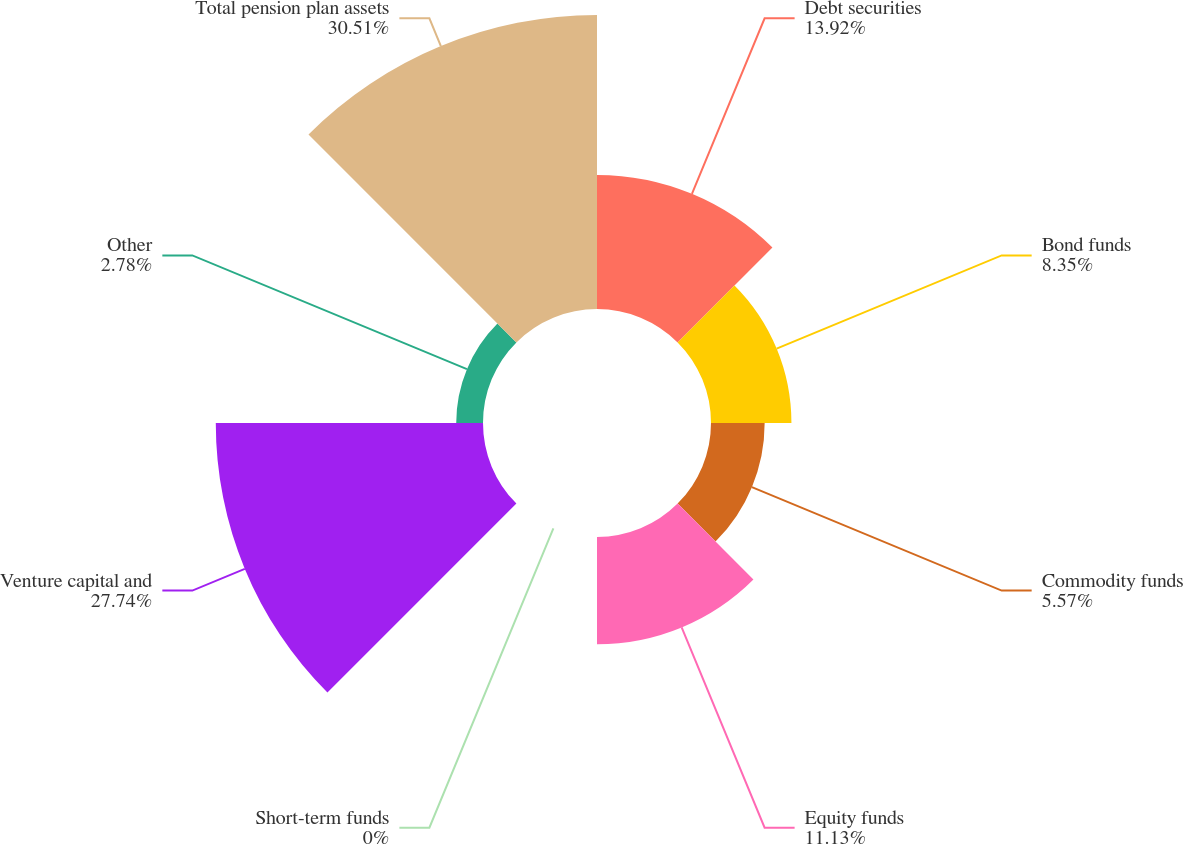Convert chart. <chart><loc_0><loc_0><loc_500><loc_500><pie_chart><fcel>Debt securities<fcel>Bond funds<fcel>Commodity funds<fcel>Equity funds<fcel>Short-term funds<fcel>Venture capital and<fcel>Other<fcel>Total pension plan assets<nl><fcel>13.92%<fcel>8.35%<fcel>5.57%<fcel>11.13%<fcel>0.0%<fcel>27.74%<fcel>2.78%<fcel>30.52%<nl></chart> 